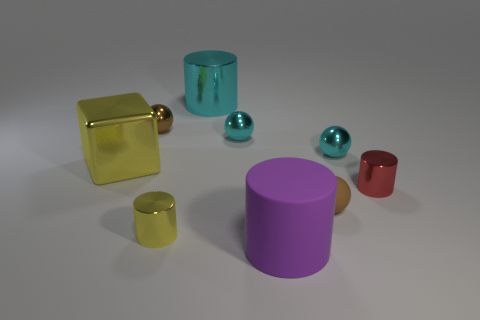Subtract all large cyan metallic cylinders. How many cylinders are left? 3 Subtract 2 spheres. How many spheres are left? 2 Subtract all purple spheres. Subtract all yellow cylinders. How many spheres are left? 4 Subtract all cylinders. How many objects are left? 5 Subtract 0 brown cylinders. How many objects are left? 9 Subtract all small yellow objects. Subtract all big yellow objects. How many objects are left? 7 Add 5 red metal cylinders. How many red metal cylinders are left? 6 Add 1 small purple metallic blocks. How many small purple metallic blocks exist? 1 